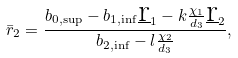Convert formula to latex. <formula><loc_0><loc_0><loc_500><loc_500>\bar { r } _ { 2 } = \frac { b _ { 0 , \sup } - b _ { 1 , \inf } \underbar r _ { 1 } - k \frac { \chi _ { 1 } } { d _ { 3 } } \underbar r _ { 2 } } { b _ { 2 , \inf } - l \frac { \chi _ { 2 } } { d _ { 3 } } } ,</formula> 